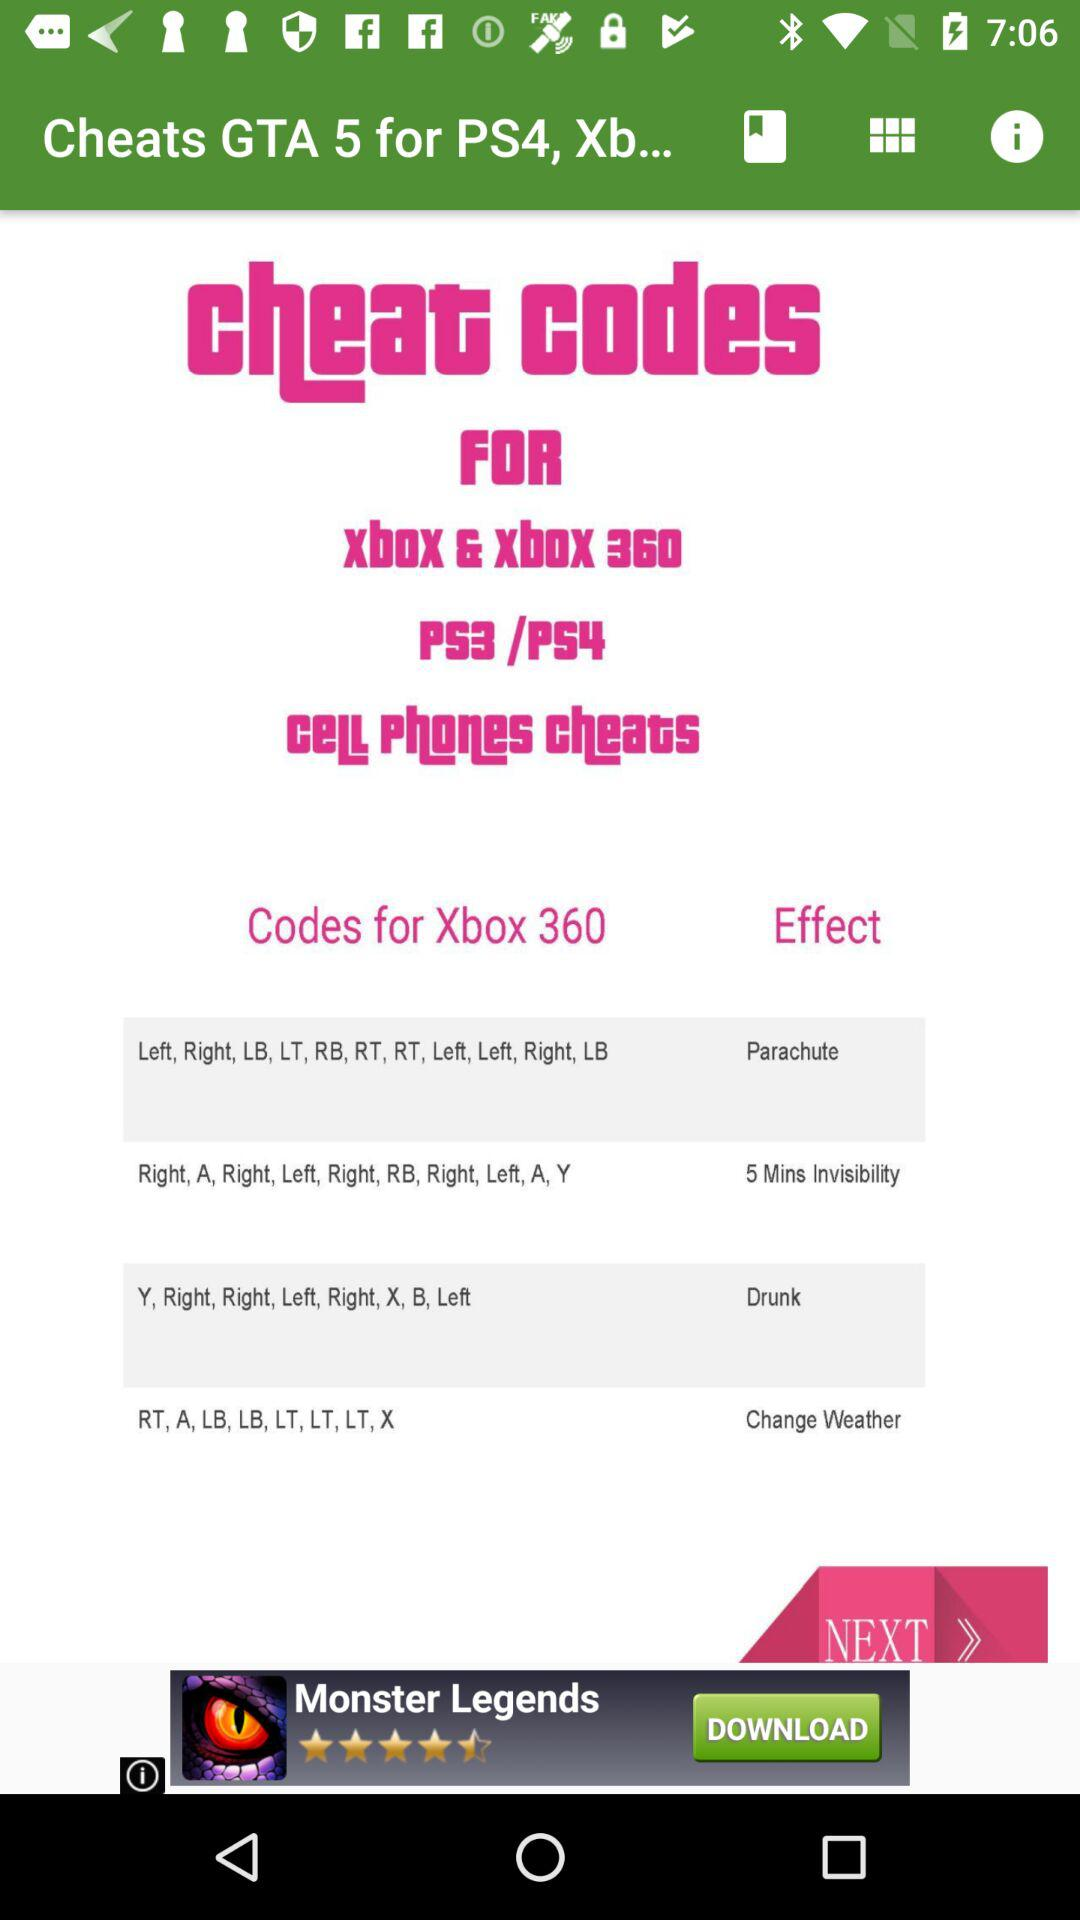How many rows of cheats are there?
Answer the question using a single word or phrase. 2 